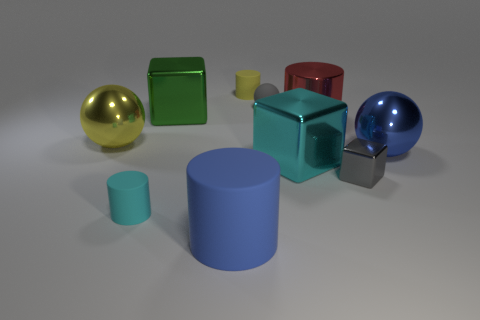How many metallic things are either small gray cylinders or spheres? In the image, there are two items that appear metallic and match the criteria: one small gray cylinder and one sphere. 